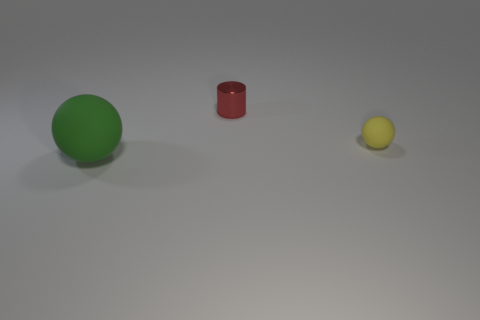Add 1 small rubber cylinders. How many objects exist? 4 Subtract all spheres. How many objects are left? 1 Subtract all large matte balls. Subtract all tiny metallic things. How many objects are left? 1 Add 2 small yellow rubber spheres. How many small yellow rubber spheres are left? 3 Add 2 big metal balls. How many big metal balls exist? 2 Subtract 0 purple cylinders. How many objects are left? 3 